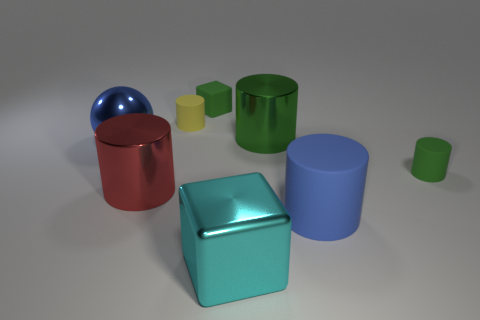How many green cylinders must be subtracted to get 1 green cylinders? 1 Add 1 blue objects. How many objects exist? 9 Subtract all green blocks. How many blocks are left? 1 Subtract all yellow rubber cylinders. How many cylinders are left? 4 Subtract all large blue matte things. Subtract all red metallic cylinders. How many objects are left? 6 Add 6 cyan things. How many cyan things are left? 7 Add 5 yellow shiny blocks. How many yellow shiny blocks exist? 5 Subtract 0 brown cylinders. How many objects are left? 8 Subtract all balls. How many objects are left? 7 Subtract all yellow balls. Subtract all purple cylinders. How many balls are left? 1 